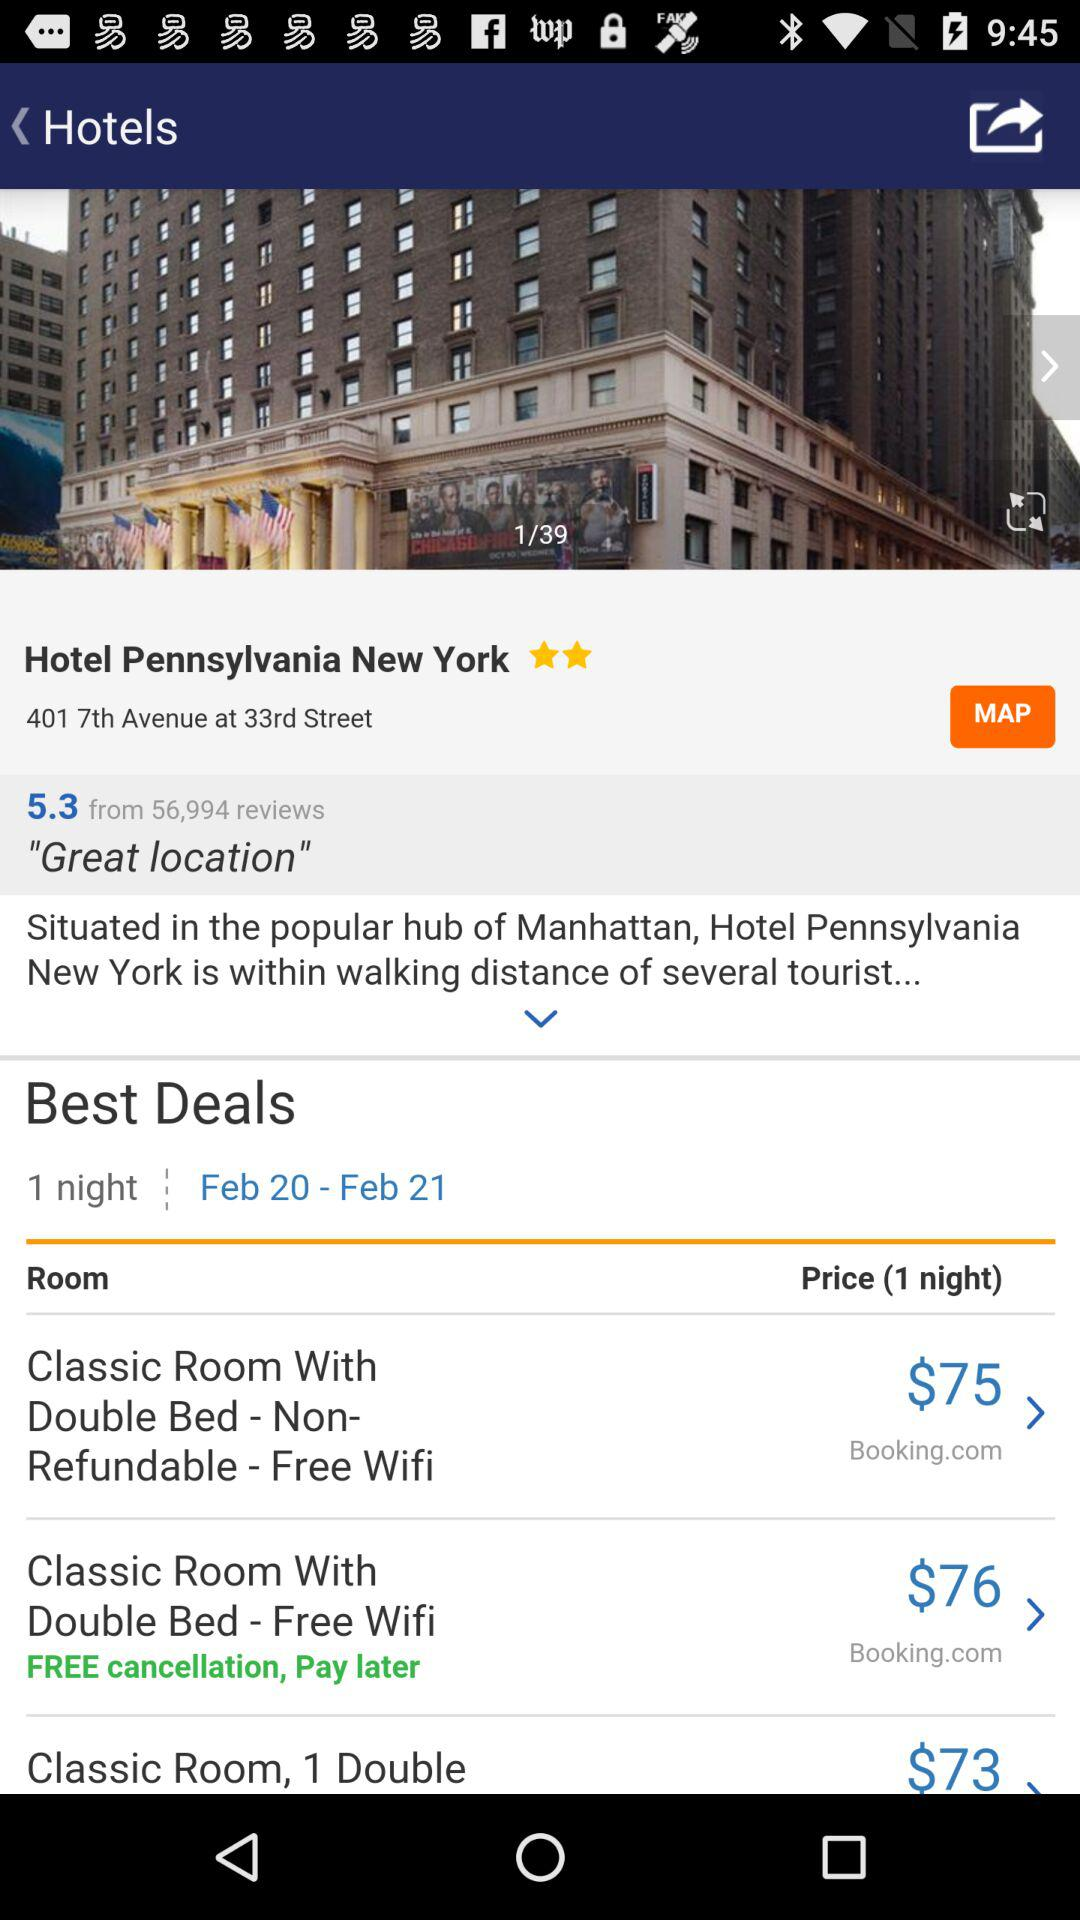What is the address of the Hotel Pennsylvania New York? The address is 401 7th Avenue at 33rd Street. 